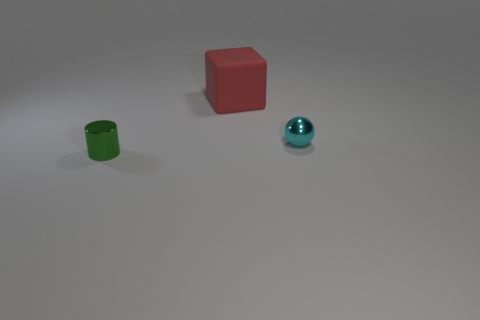Add 1 big red objects. How many objects exist? 4 Subtract all cubes. How many objects are left? 2 Subtract all big matte things. Subtract all tiny blue matte cylinders. How many objects are left? 2 Add 2 cyan metal balls. How many cyan metal balls are left? 3 Add 3 tiny green objects. How many tiny green objects exist? 4 Subtract 0 purple balls. How many objects are left? 3 